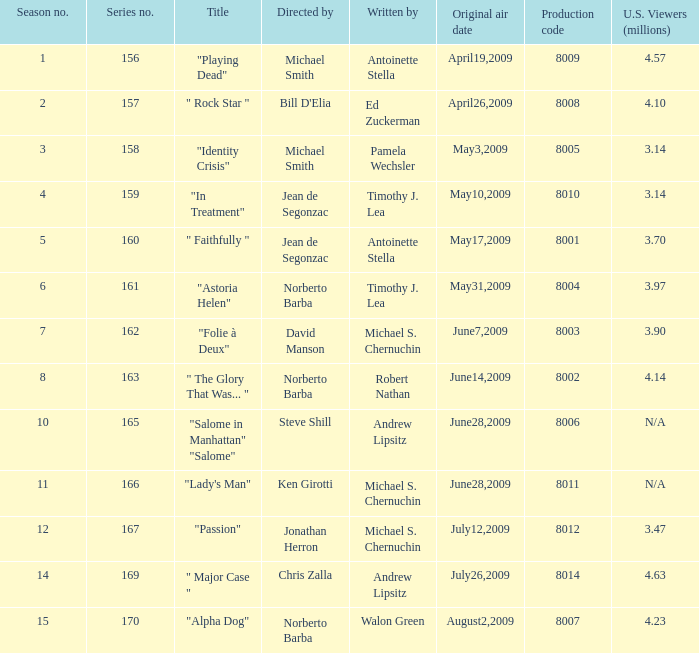How many scribes create the episode directed by jonathan herron? 1.0. 